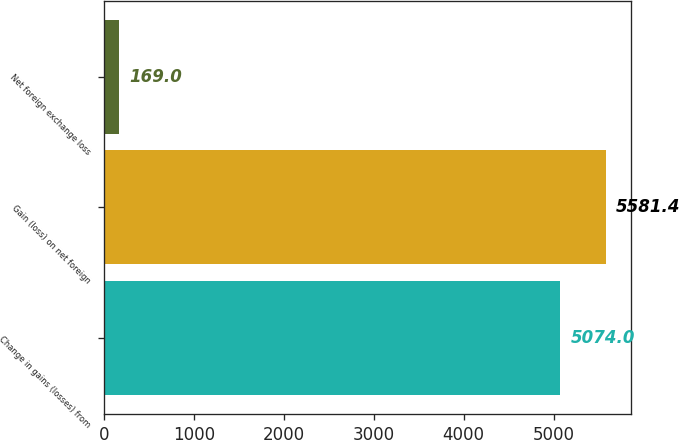<chart> <loc_0><loc_0><loc_500><loc_500><bar_chart><fcel>Change in gains (losses) from<fcel>Gain (loss) on net foreign<fcel>Net foreign exchange loss<nl><fcel>5074<fcel>5581.4<fcel>169<nl></chart> 